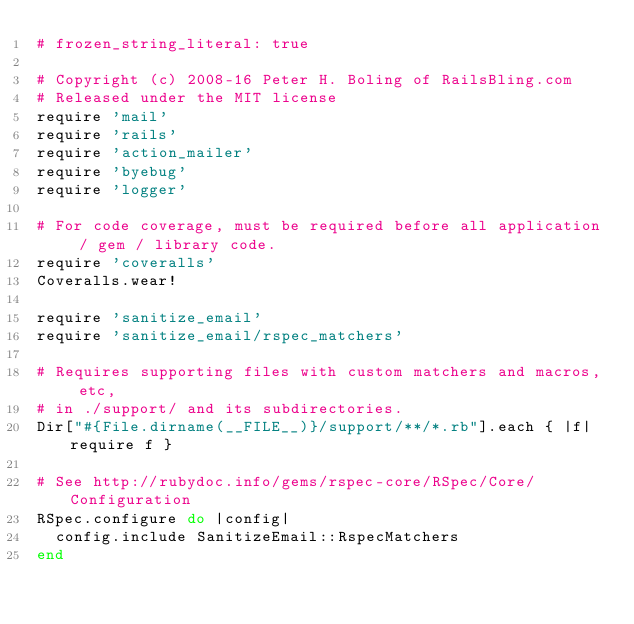<code> <loc_0><loc_0><loc_500><loc_500><_Ruby_># frozen_string_literal: true

# Copyright (c) 2008-16 Peter H. Boling of RailsBling.com
# Released under the MIT license
require 'mail'
require 'rails'
require 'action_mailer'
require 'byebug'
require 'logger'

# For code coverage, must be required before all application / gem / library code.
require 'coveralls'
Coveralls.wear!

require 'sanitize_email'
require 'sanitize_email/rspec_matchers'

# Requires supporting files with custom matchers and macros, etc,
# in ./support/ and its subdirectories.
Dir["#{File.dirname(__FILE__)}/support/**/*.rb"].each { |f| require f }

# See http://rubydoc.info/gems/rspec-core/RSpec/Core/Configuration
RSpec.configure do |config|
  config.include SanitizeEmail::RspecMatchers
end
</code> 